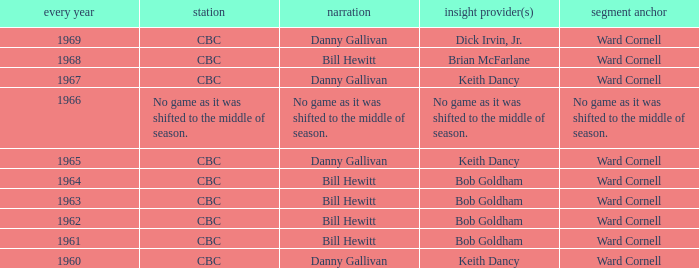Were the color commentators who worked with Bill Hewitt doing the play-by-play? Brian McFarlane, Bob Goldham, Bob Goldham, Bob Goldham, Bob Goldham. 